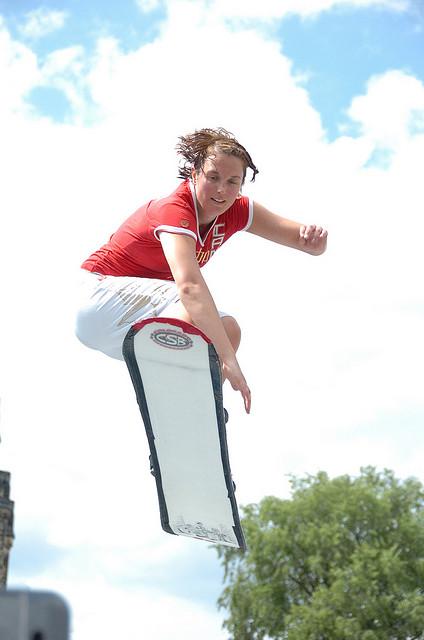What is the shirt written?
Keep it brief. Cp. Is this person male or female?
Concise answer only. Male. What color is his shirt?
Concise answer only. Red. What is this person riding?
Give a very brief answer. Snowboard. What color is his hair?
Keep it brief. Brown. How are the ladies hands?
Be succinct. Clean. 